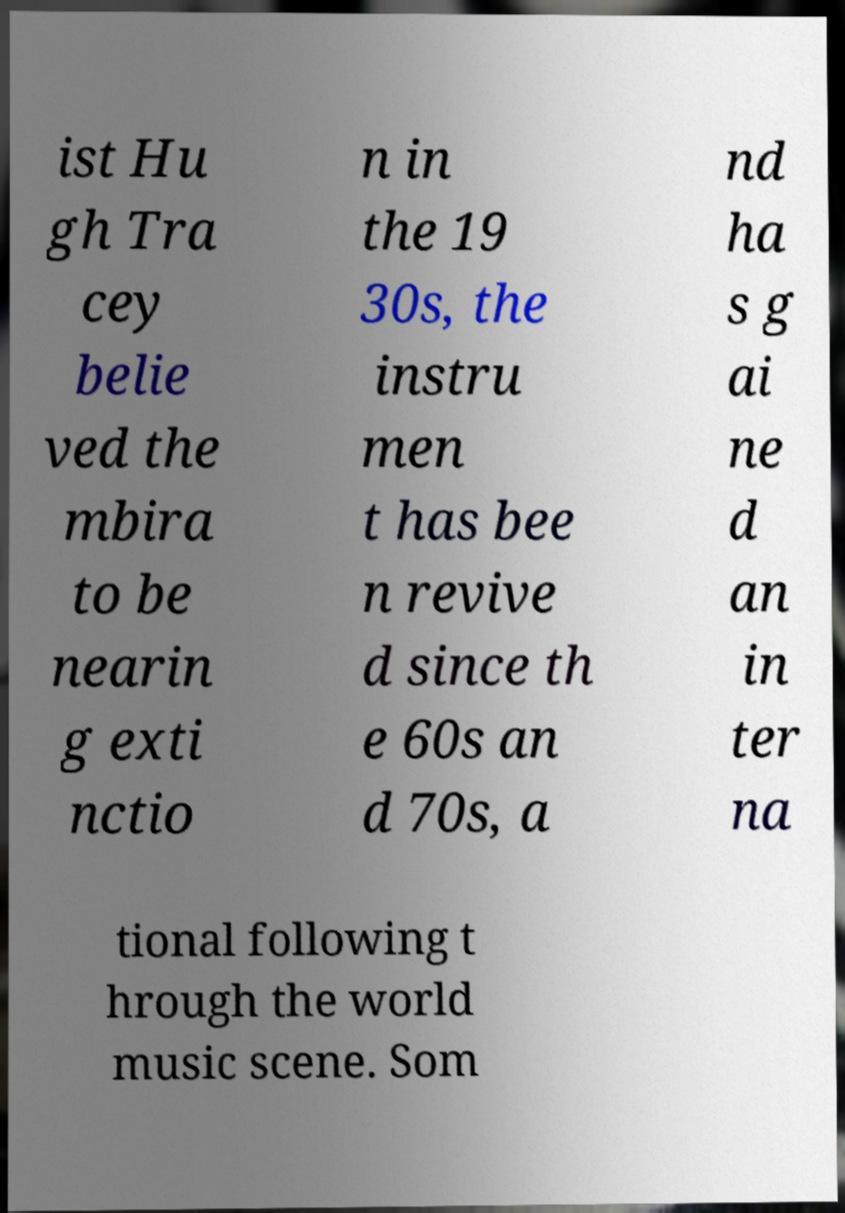For documentation purposes, I need the text within this image transcribed. Could you provide that? ist Hu gh Tra cey belie ved the mbira to be nearin g exti nctio n in the 19 30s, the instru men t has bee n revive d since th e 60s an d 70s, a nd ha s g ai ne d an in ter na tional following t hrough the world music scene. Som 